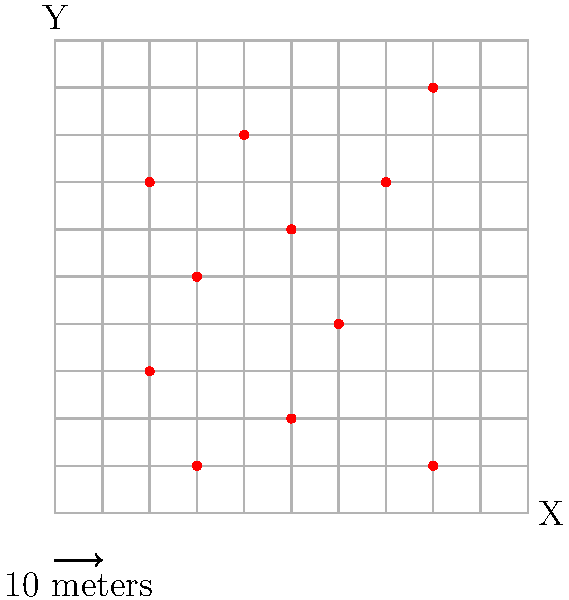As a retired teacher, you're helping organize a community event. You're given an aerial view of a crowd, represented by a 10x10 grid where each cell is 10 meters square. Red dots indicate people. Using the density-based method, estimate the total number of people in the crowd if the entire area is filled similarly. To estimate the total number of people in the crowd using the density-based method, we'll follow these steps:

1. Count the number of people (red dots) in the given sample area:
   There are 11 red dots in the 10x10 grid.

2. Calculate the area of the sample:
   The grid is 10x10, and each cell is 10 meters square.
   Area = 10 * 10 * 10² = 1000 m²

3. Calculate the density of people per square meter:
   Density = Number of people / Area
   Density = 11 / 1000 = 0.011 people/m²

4. Assuming the entire event area is filled similarly, we need to estimate the total area:
   Let's assume the total area is 100 times larger than our sample.
   Total area = 1000 m² * 100 = 100,000 m²

5. Estimate the total number of people:
   Total people = Density * Total area
   Total people = 0.011 * 100,000 = 1,100

Therefore, if the entire area is filled similarly to our sample, we estimate there would be approximately 1,100 people in the crowd.
Answer: 1,100 people 